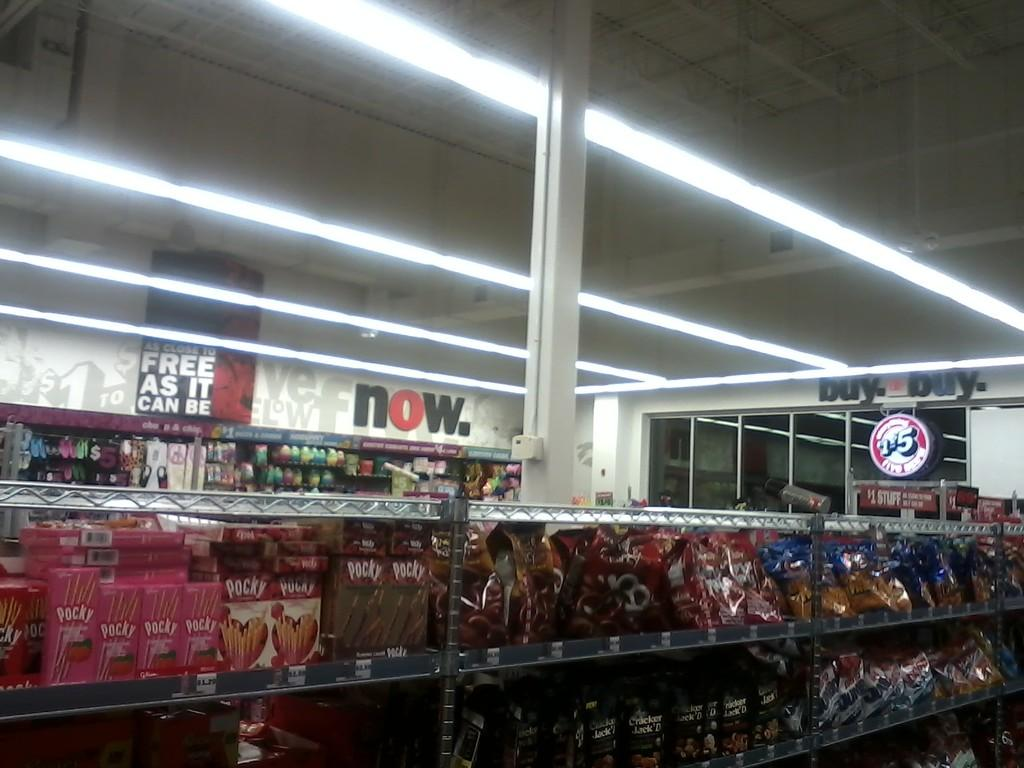<image>
Share a concise interpretation of the image provided. A store has a sign that says Buy Buy on the wall. 